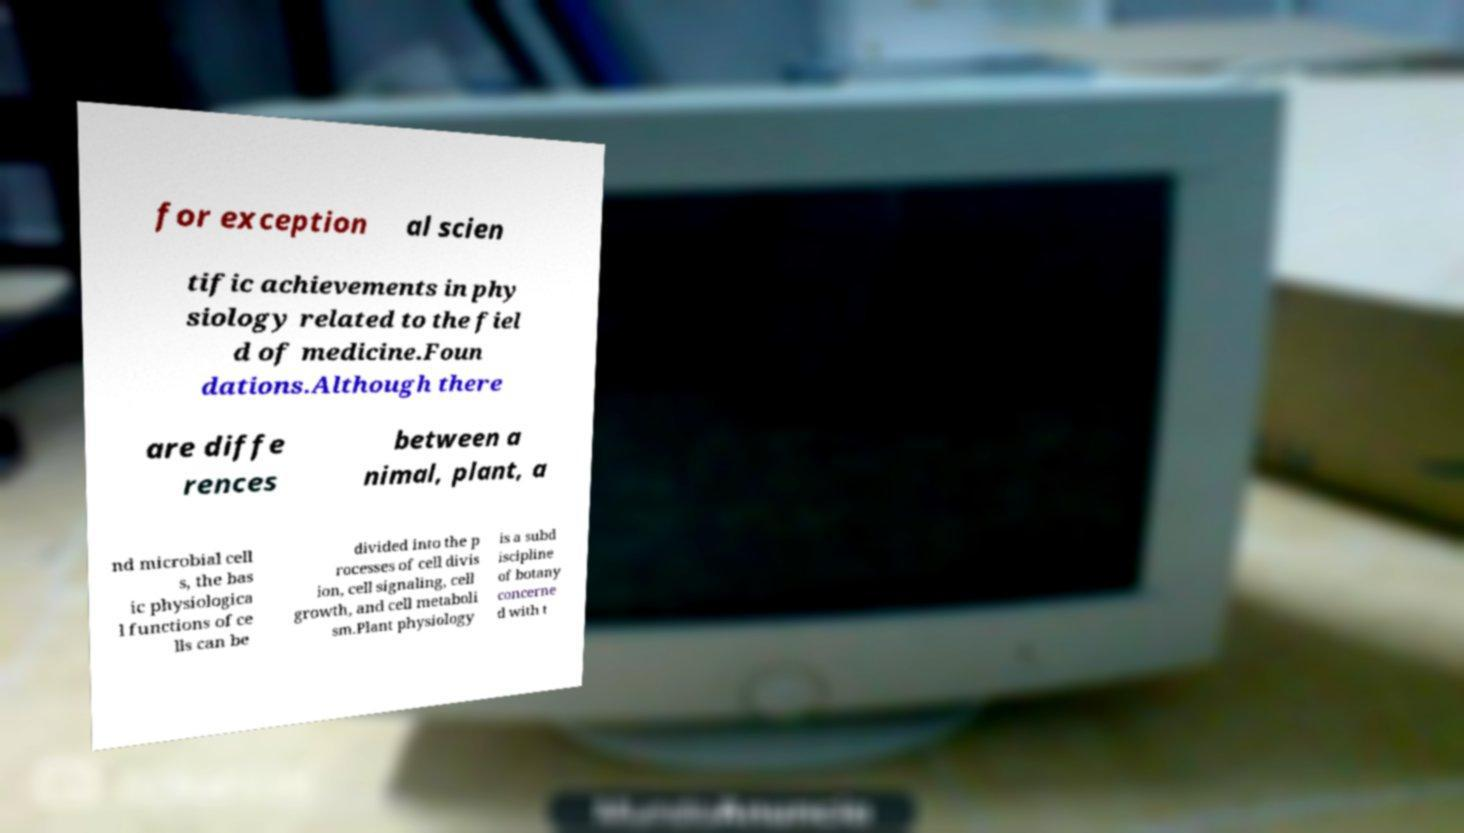Can you read and provide the text displayed in the image?This photo seems to have some interesting text. Can you extract and type it out for me? for exception al scien tific achievements in phy siology related to the fiel d of medicine.Foun dations.Although there are diffe rences between a nimal, plant, a nd microbial cell s, the bas ic physiologica l functions of ce lls can be divided into the p rocesses of cell divis ion, cell signaling, cell growth, and cell metaboli sm.Plant physiology is a subd iscipline of botany concerne d with t 